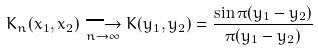<formula> <loc_0><loc_0><loc_500><loc_500>K _ { n } ( x _ { 1 } , x _ { 2 } ) \underset { n \rightarrow \infty } { \longrightarrow } K ( y _ { 1 } , y _ { 2 } ) = \frac { \sin \pi ( y _ { 1 } - y _ { 2 } ) } { \pi ( y _ { 1 } - y _ { 2 } ) }</formula> 